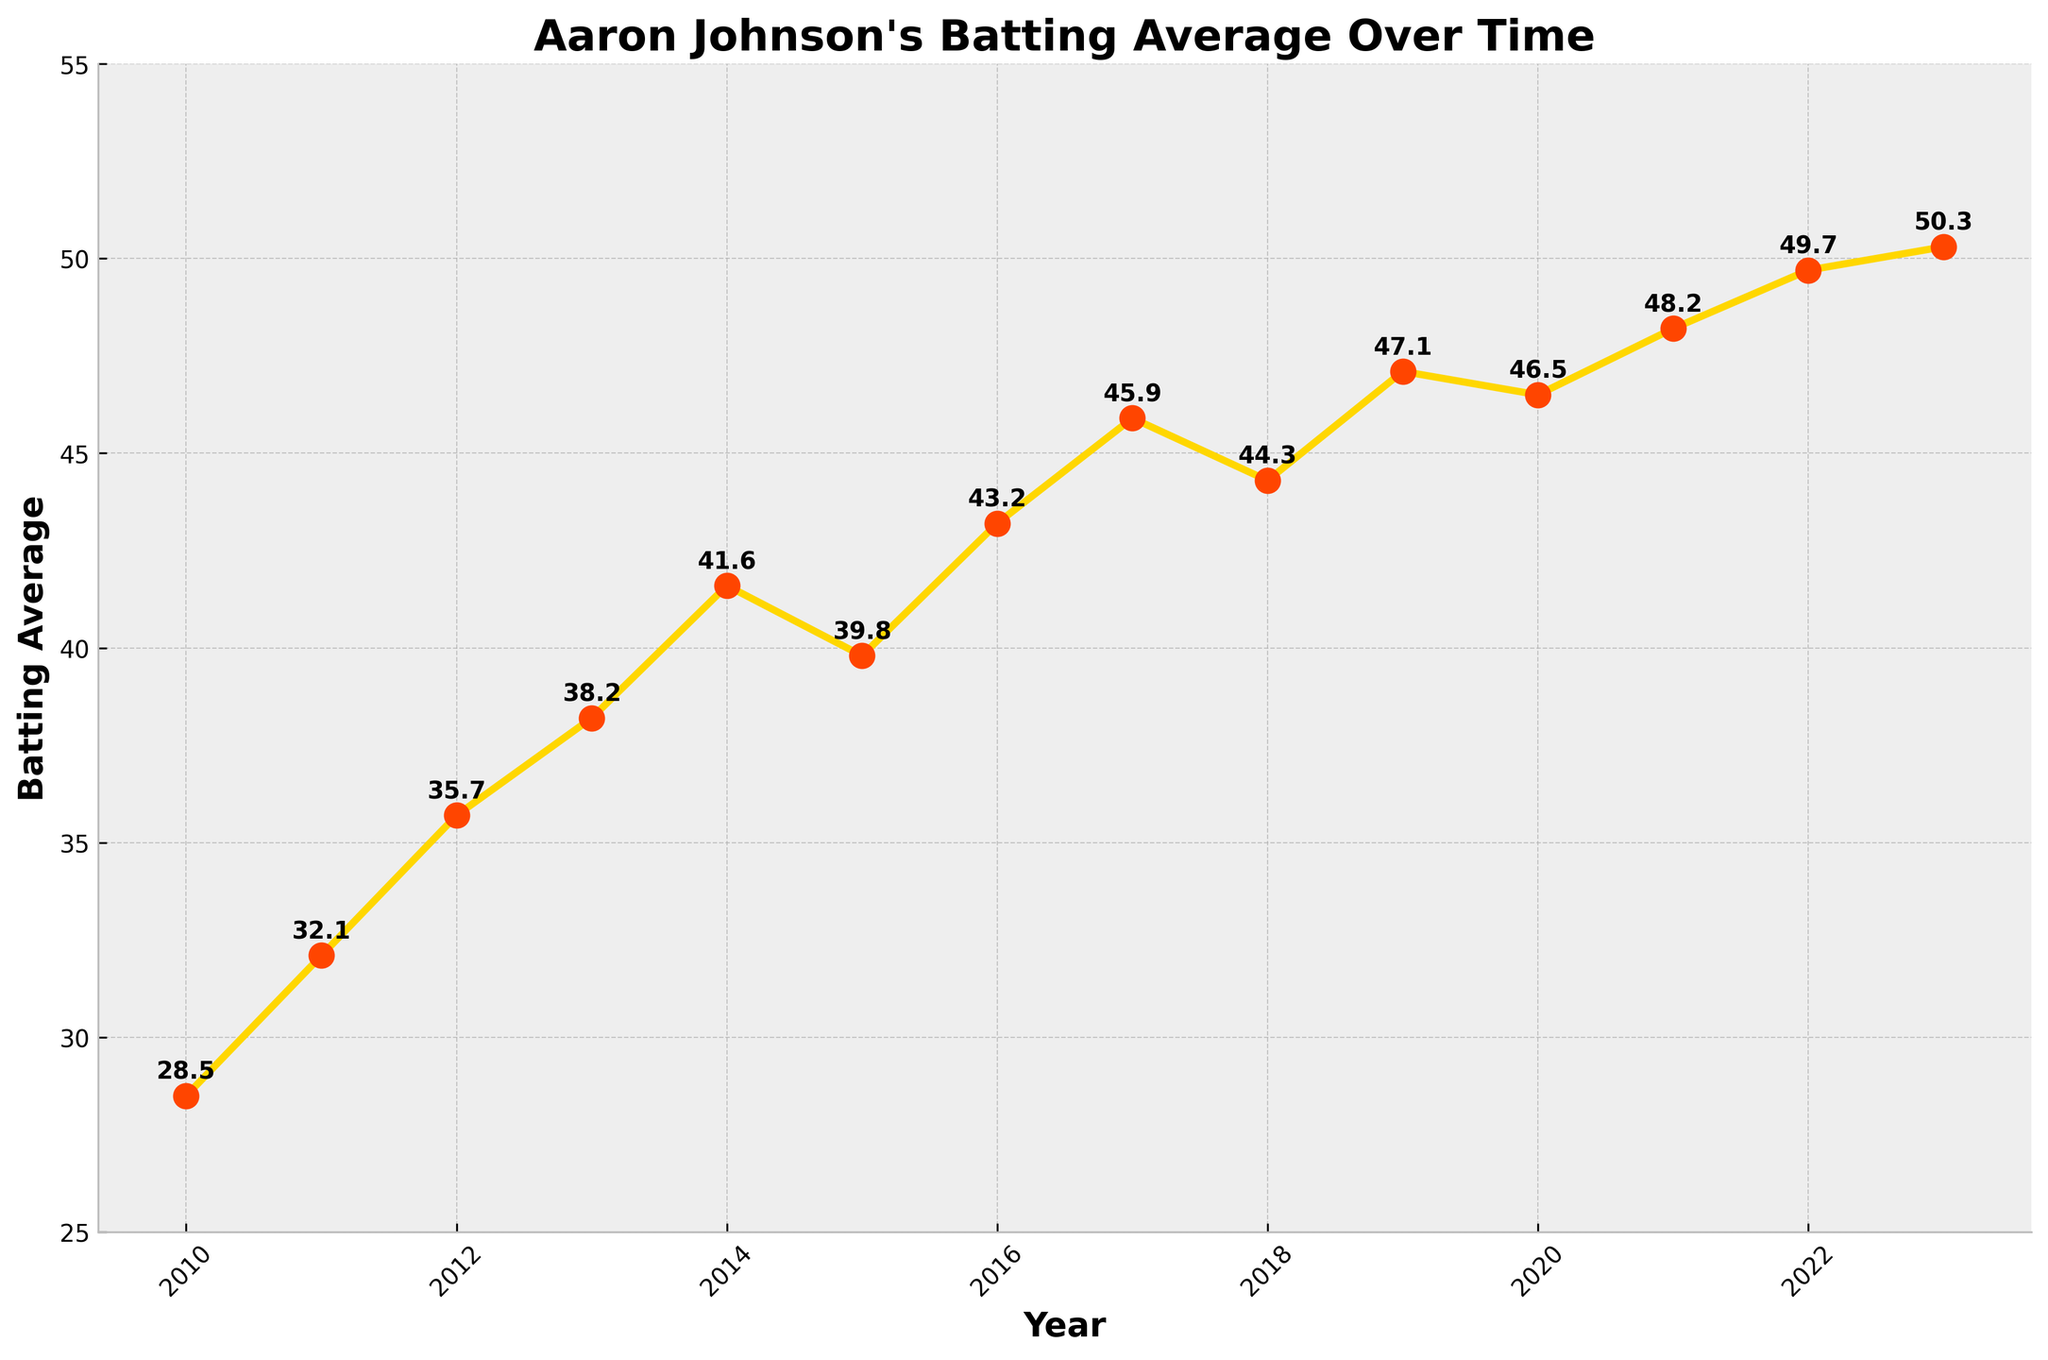What year did Aaron Johnson have the highest batting average? Look at the graph and find the highest point on the line representing the batting average, then check the corresponding year on the x-axis.
Answer: 2023 What was Aaron Johnson's batting average in 2010? Locate the year 2010 on the x-axis and read the value on the y-axis where the line chart corresponds to this year.
Answer: 28.5 By how much did Aaron Johnson's batting average increase from 2010 to 2013? Find the batting averages for 2010 and 2013 and subtract the value for 2010 from the value for 2013 (38.2 - 28.5).
Answer: 9.7 Compare Aaron Johnson's batting average between 2015 and 2016. Which year had a higher average? Locate the points corresponding to 2015 and 2016 on the graph and compare the y-values of these points to see which one is higher.
Answer: 2016 What is the average batting average from 2010 to 2013 inclusive? Sum the batting averages from 2010 to 2013 and divide by the number of years (28.5 + 32.1 + 35.7 + 38.2) / 4.
Answer: 33.6 In which year did Aaron Johnson's batting average first exceed 40? Examine the values along the y-axis and find the year where the batting average is just above 40 for the first time.
Answer: 2014 Was there any year when Aaron Johnson's batting average decreased compared to the previous year? If yes, name one such year. Look at the trend of the line; if it slopes downward, the batting average has decreased. Identify the point immediately after a downward slope.
Answer: 2015 What is the total increase in Aaron Johnson's batting average from 2010 to 2023? Subtract the average in 2010 from that in 2023 (50.3 - 28.5).
Answer: 21.8 How many years did Aaron Johnson's batting average increase consecutively from 2011 through 2017? Count the years from 2011 to 2017 and check if each succeeding year's average is higher than the previous year's average.
Answer: 7 years What is the median batting average from 2010 to 2023? Arrange the batting averages in ascending order and find the middle value. With 14 values, the median is the average of the 7th and 8th values (43.2 and 45.9).
Answer: 44.5 